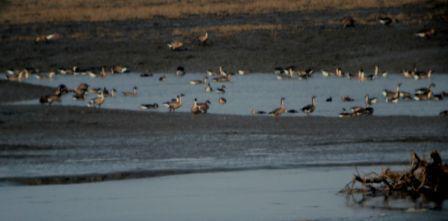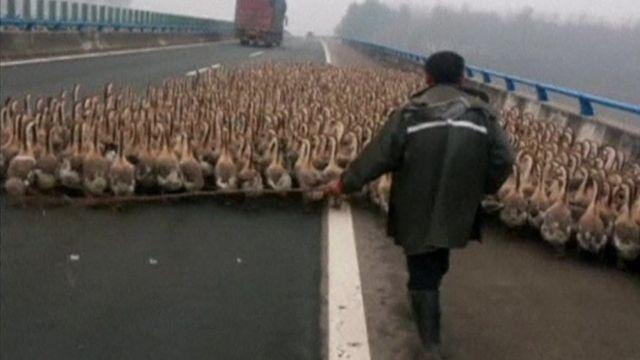The first image is the image on the left, the second image is the image on the right. Assess this claim about the two images: "There is an officer with yellow marked clothing in the street in one of the images.". Correct or not? Answer yes or no. No. The first image is the image on the left, the second image is the image on the right. Given the left and right images, does the statement "There are some police involved, where the geese are blocking the street." hold true? Answer yes or no. No. 